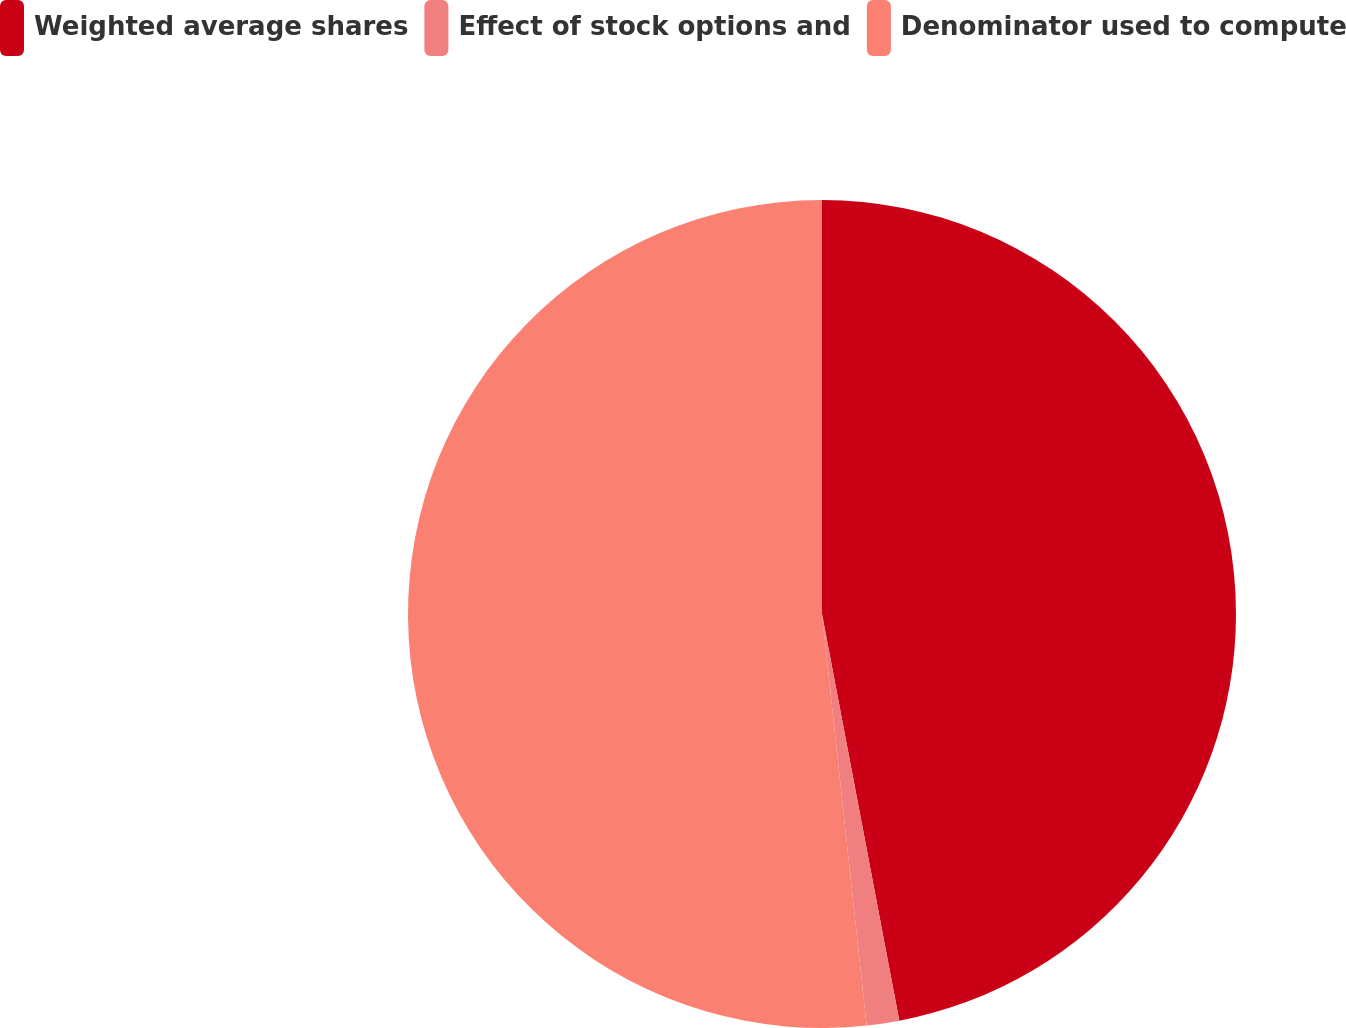<chart> <loc_0><loc_0><loc_500><loc_500><pie_chart><fcel>Weighted average shares<fcel>Effect of stock options and<fcel>Denominator used to compute<nl><fcel>47.01%<fcel>1.27%<fcel>51.72%<nl></chart> 